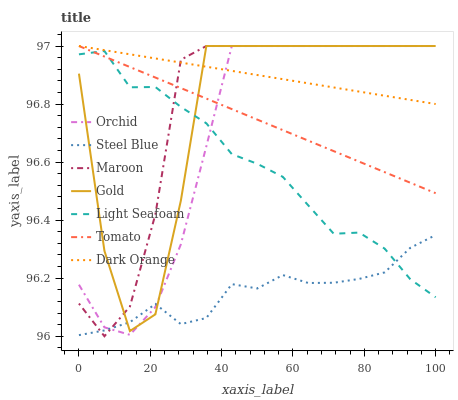Does Steel Blue have the minimum area under the curve?
Answer yes or no. Yes. Does Dark Orange have the maximum area under the curve?
Answer yes or no. Yes. Does Gold have the minimum area under the curve?
Answer yes or no. No. Does Gold have the maximum area under the curve?
Answer yes or no. No. Is Tomato the smoothest?
Answer yes or no. Yes. Is Gold the roughest?
Answer yes or no. Yes. Is Dark Orange the smoothest?
Answer yes or no. No. Is Dark Orange the roughest?
Answer yes or no. No. Does Maroon have the lowest value?
Answer yes or no. Yes. Does Gold have the lowest value?
Answer yes or no. No. Does Orchid have the highest value?
Answer yes or no. Yes. Does Steel Blue have the highest value?
Answer yes or no. No. Is Light Seafoam less than Dark Orange?
Answer yes or no. Yes. Is Dark Orange greater than Steel Blue?
Answer yes or no. Yes. Does Light Seafoam intersect Gold?
Answer yes or no. Yes. Is Light Seafoam less than Gold?
Answer yes or no. No. Is Light Seafoam greater than Gold?
Answer yes or no. No. Does Light Seafoam intersect Dark Orange?
Answer yes or no. No. 